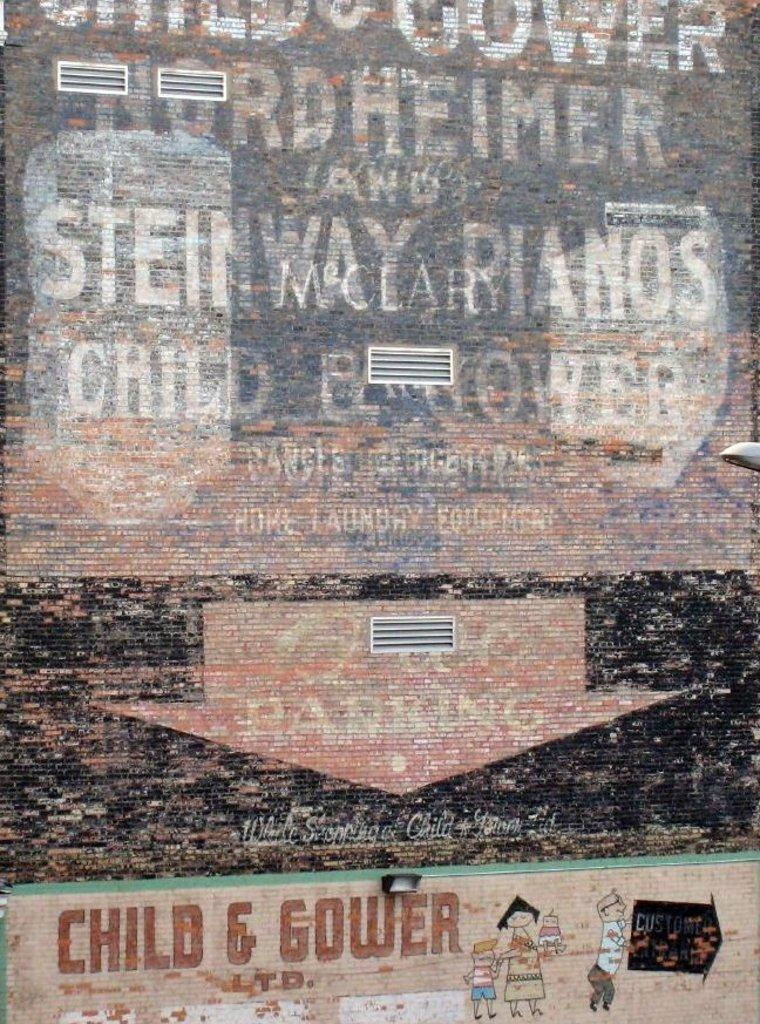<image>
Render a clear and concise summary of the photo. A faded advertisement for Child and Gower for pianos. 